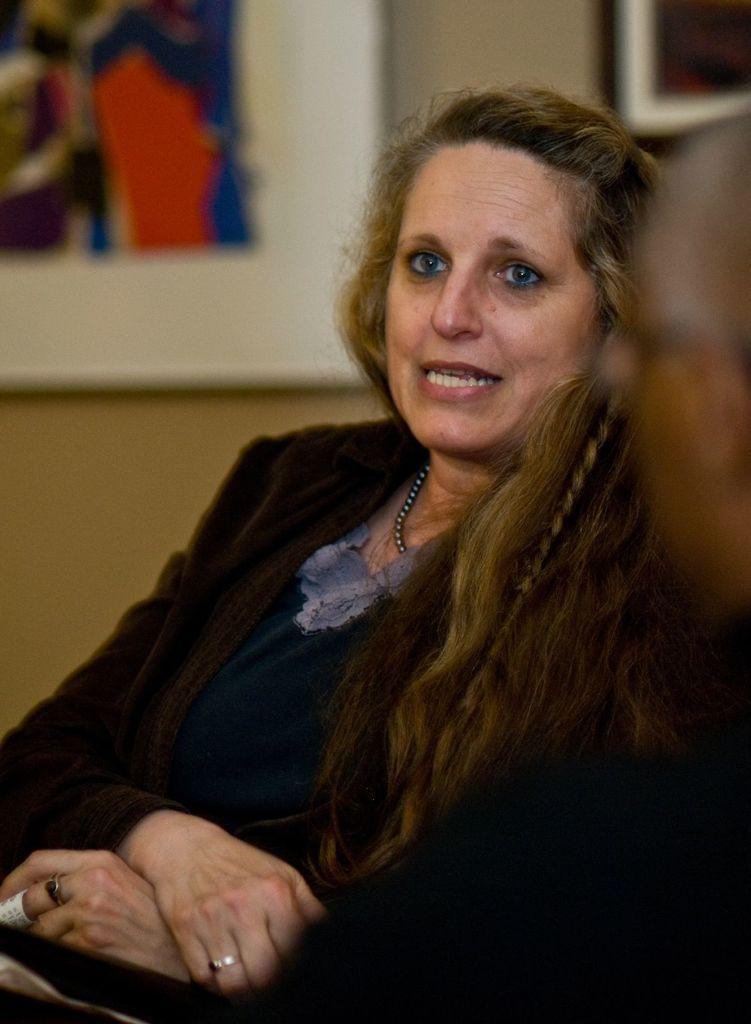Please provide a concise description of this image. In this image there is a lady sitting, beside her there is a person. In the background there are frames hanging on the wall. 